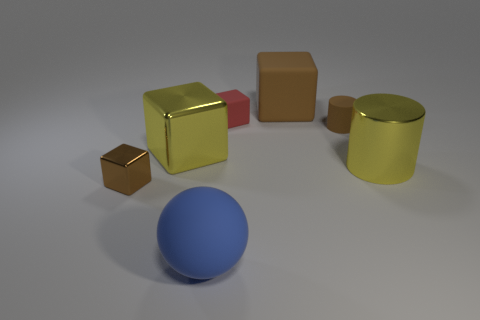There is a small block that is left of the large yellow shiny object that is left of the matte ball; what is its color?
Your answer should be very brief. Brown. Are there more big objects that are right of the big shiny cube than small brown rubber cylinders that are on the left side of the large brown thing?
Offer a very short reply. Yes. Do the tiny brown object that is on the left side of the big blue rubber object and the cube to the right of the red block have the same material?
Provide a short and direct response. No. Are there any brown rubber blocks to the left of the tiny red matte object?
Your answer should be compact. No. What number of green objects are large rubber things or tiny cylinders?
Offer a terse response. 0. Does the big blue thing have the same material as the big yellow object to the left of the tiny brown cylinder?
Provide a short and direct response. No. There is another red thing that is the same shape as the tiny shiny thing; what size is it?
Offer a terse response. Small. What is the material of the big yellow cube?
Offer a very short reply. Metal. What is the yellow object that is behind the big metal object to the right of the small brown object that is on the right side of the small brown shiny object made of?
Your response must be concise. Metal. There is a block in front of the yellow block; is it the same size as the brown cylinder that is behind the yellow metal cylinder?
Offer a very short reply. Yes. 